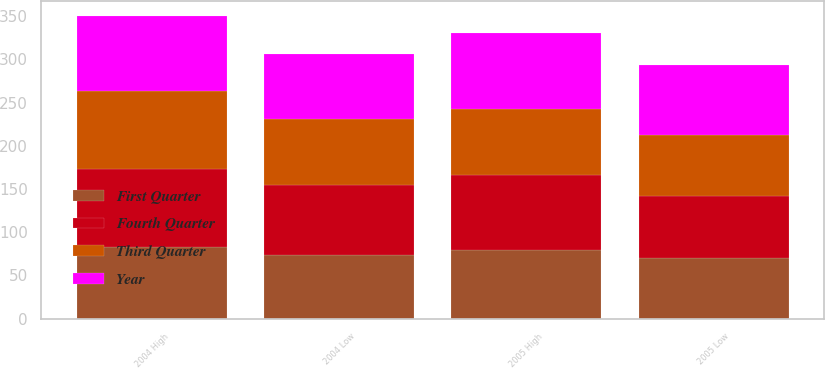Convert chart. <chart><loc_0><loc_0><loc_500><loc_500><stacked_bar_chart><ecel><fcel>2005 High<fcel>2005 Low<fcel>2004 High<fcel>2004 Low<nl><fcel>Year<fcel>87.45<fcel>80.73<fcel>86.2<fcel>74.35<nl><fcel>Fourth Quarter<fcel>86.21<fcel>72.25<fcel>90.29<fcel>80.9<nl><fcel>Third Quarter<fcel>76.74<fcel>70.41<fcel>90.11<fcel>77.2<nl><fcel>First Quarter<fcel>79.84<fcel>69.71<fcel>83.03<fcel>73.31<nl></chart> 